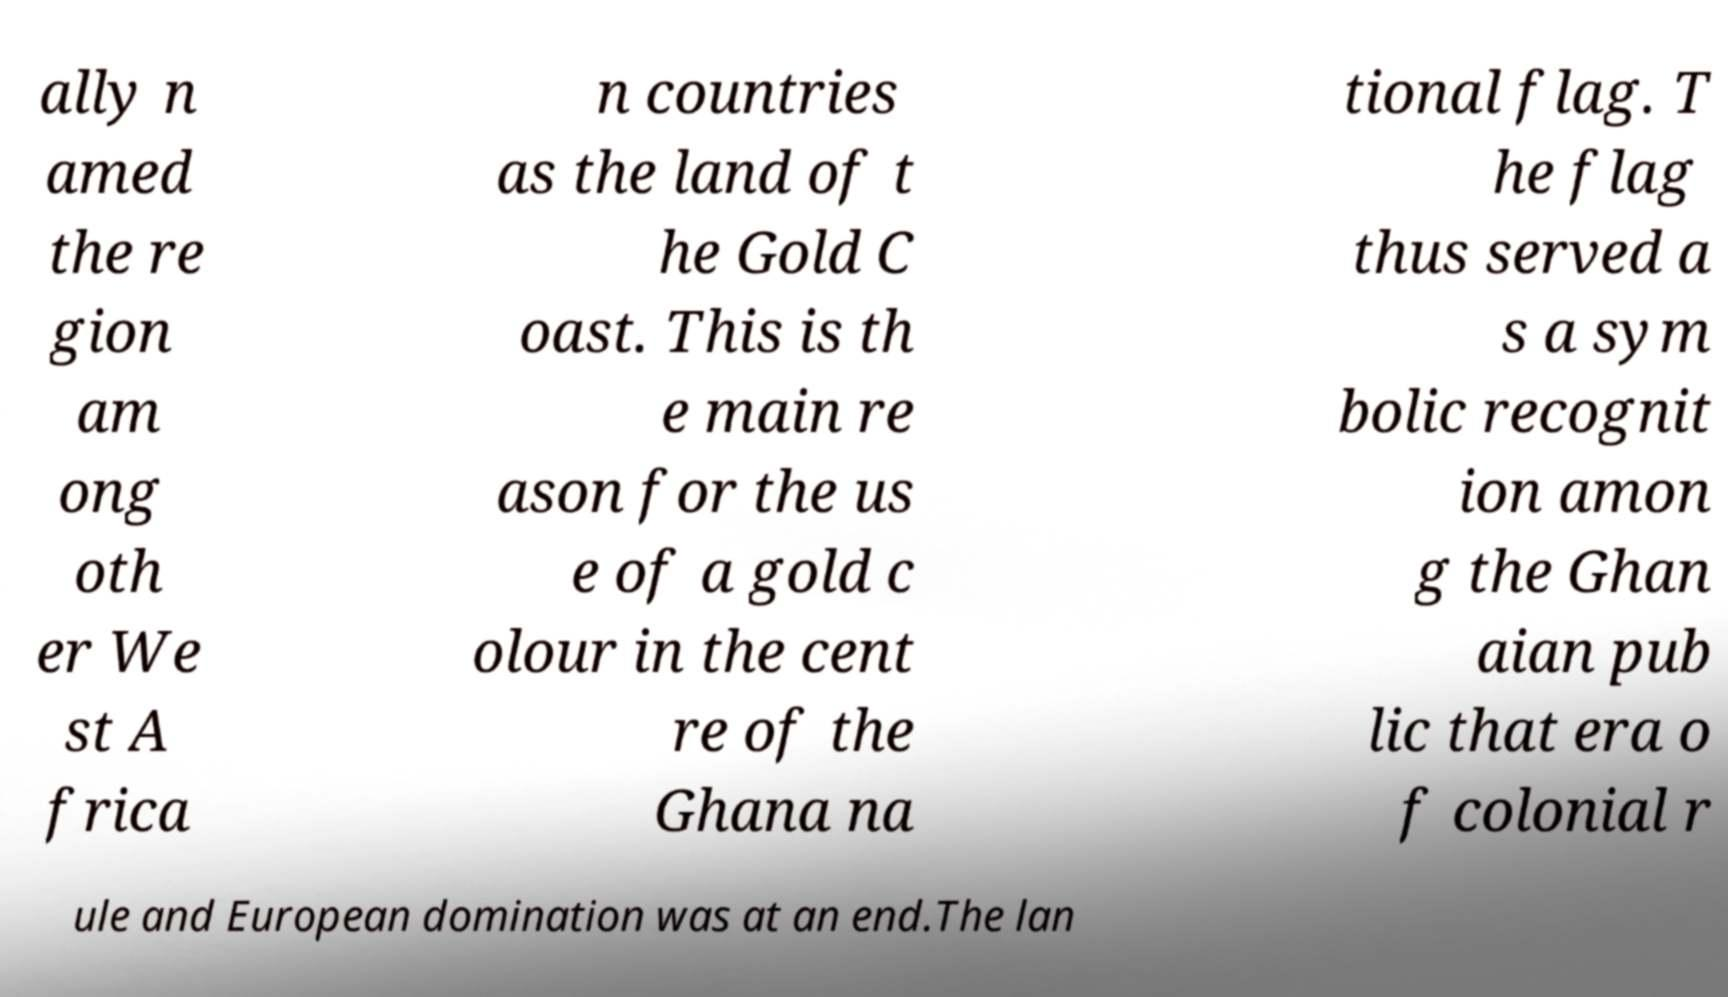What messages or text are displayed in this image? I need them in a readable, typed format. ally n amed the re gion am ong oth er We st A frica n countries as the land of t he Gold C oast. This is th e main re ason for the us e of a gold c olour in the cent re of the Ghana na tional flag. T he flag thus served a s a sym bolic recognit ion amon g the Ghan aian pub lic that era o f colonial r ule and European domination was at an end.The lan 